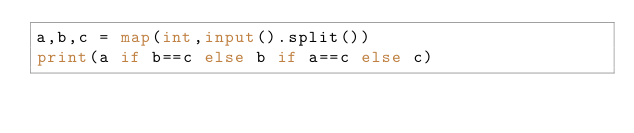Convert code to text. <code><loc_0><loc_0><loc_500><loc_500><_Python_>a,b,c = map(int,input().split())
print(a if b==c else b if a==c else c)</code> 